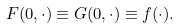Convert formula to latex. <formula><loc_0><loc_0><loc_500><loc_500>F ( 0 , \cdot ) \equiv G ( 0 , \cdot ) \equiv f ( \cdot ) .</formula> 